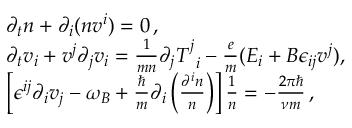Convert formula to latex. <formula><loc_0><loc_0><loc_500><loc_500>\begin{array} { r l } & { \partial _ { t } n + \partial _ { i } ( n v ^ { i } ) = 0 \, , } \\ & { \partial _ { t } v _ { i } + v ^ { j } \partial _ { j } v _ { i } = \frac { 1 } { m n } \partial _ { j } T _ { \, i } ^ { j } - \frac { e } { m } ( E _ { i } + B \epsilon _ { i j } v ^ { j } ) , } \\ & { \left [ \epsilon ^ { i j } \partial _ { i } v _ { j } - \omega _ { B } + \frac { } { m } \partial _ { i } \left ( \frac { \partial ^ { i } n } { n } \right ) \right ] \frac { 1 } { n } = - \frac { 2 \pi } { \nu m } \, , } \end{array}</formula> 